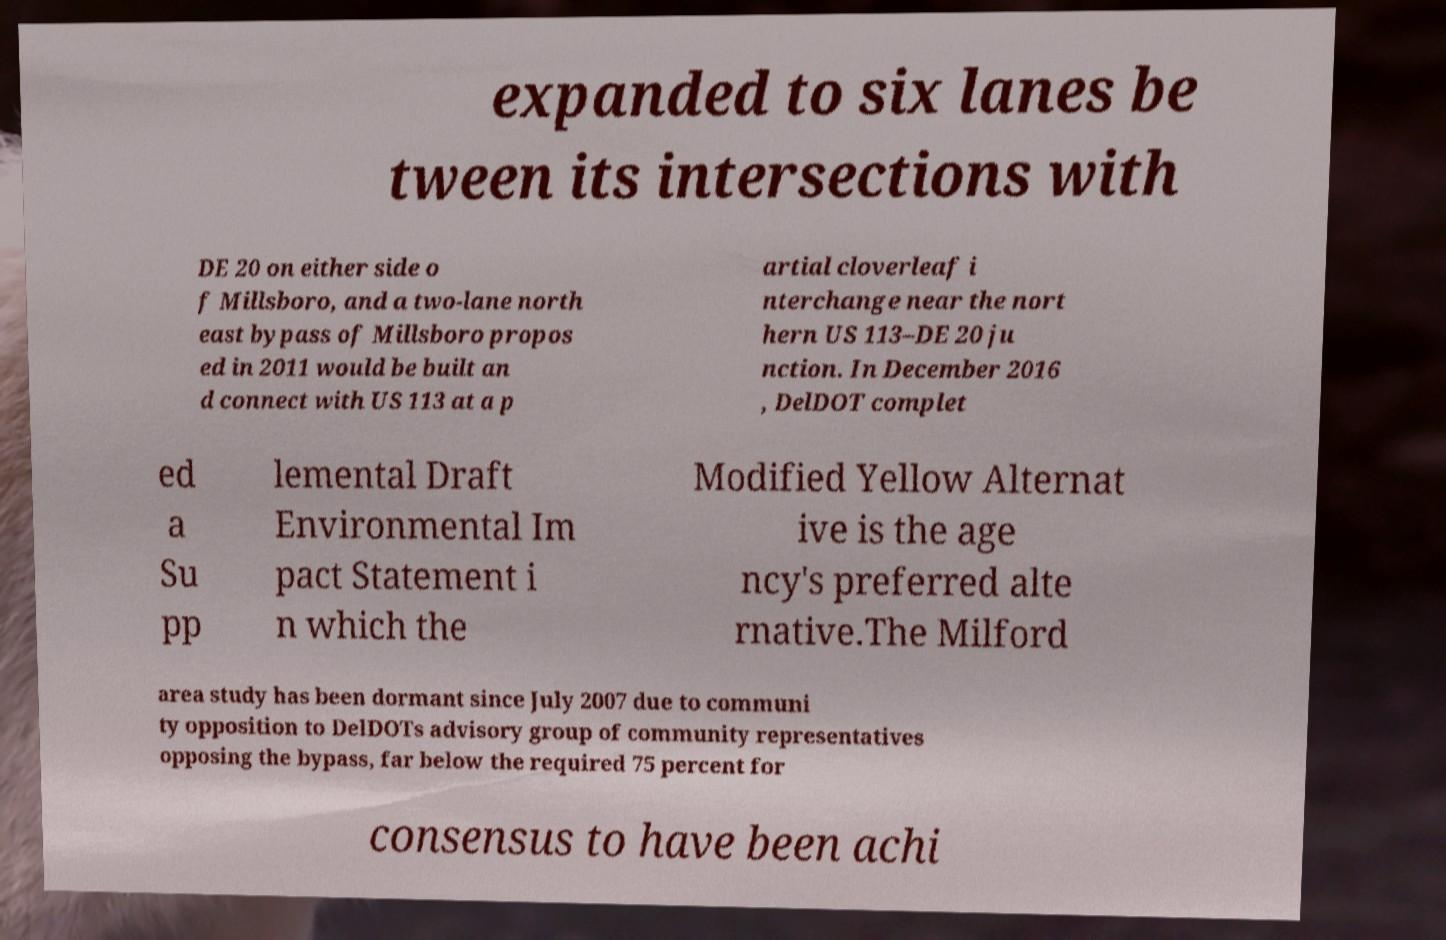Could you assist in decoding the text presented in this image and type it out clearly? expanded to six lanes be tween its intersections with DE 20 on either side o f Millsboro, and a two-lane north east bypass of Millsboro propos ed in 2011 would be built an d connect with US 113 at a p artial cloverleaf i nterchange near the nort hern US 113–DE 20 ju nction. In December 2016 , DelDOT complet ed a Su pp lemental Draft Environmental Im pact Statement i n which the Modified Yellow Alternat ive is the age ncy's preferred alte rnative.The Milford area study has been dormant since July 2007 due to communi ty opposition to DelDOTs advisory group of community representatives opposing the bypass, far below the required 75 percent for consensus to have been achi 